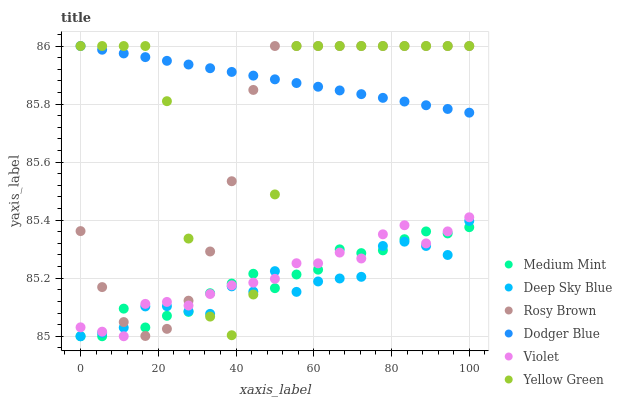Does Deep Sky Blue have the minimum area under the curve?
Answer yes or no. Yes. Does Dodger Blue have the maximum area under the curve?
Answer yes or no. Yes. Does Yellow Green have the minimum area under the curve?
Answer yes or no. No. Does Yellow Green have the maximum area under the curve?
Answer yes or no. No. Is Dodger Blue the smoothest?
Answer yes or no. Yes. Is Yellow Green the roughest?
Answer yes or no. Yes. Is Rosy Brown the smoothest?
Answer yes or no. No. Is Rosy Brown the roughest?
Answer yes or no. No. Does Medium Mint have the lowest value?
Answer yes or no. Yes. Does Yellow Green have the lowest value?
Answer yes or no. No. Does Dodger Blue have the highest value?
Answer yes or no. Yes. Does Deep Sky Blue have the highest value?
Answer yes or no. No. Is Medium Mint less than Dodger Blue?
Answer yes or no. Yes. Is Dodger Blue greater than Medium Mint?
Answer yes or no. Yes. Does Medium Mint intersect Violet?
Answer yes or no. Yes. Is Medium Mint less than Violet?
Answer yes or no. No. Is Medium Mint greater than Violet?
Answer yes or no. No. Does Medium Mint intersect Dodger Blue?
Answer yes or no. No. 